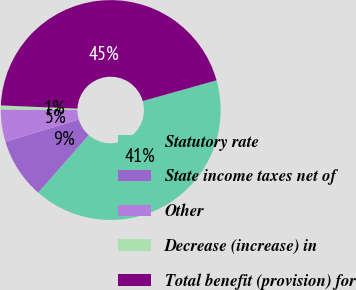Convert chart to OTSL. <chart><loc_0><loc_0><loc_500><loc_500><pie_chart><fcel>Statutory rate<fcel>State income taxes net of<fcel>Other<fcel>Decrease (increase) in<fcel>Total benefit (provision) for<nl><fcel>40.82%<fcel>8.89%<fcel>4.74%<fcel>0.58%<fcel>44.97%<nl></chart> 